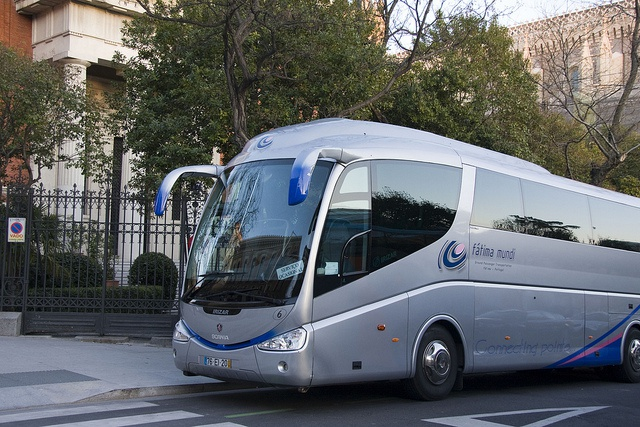Describe the objects in this image and their specific colors. I can see bus in brown, black, gray, and darkgray tones in this image. 